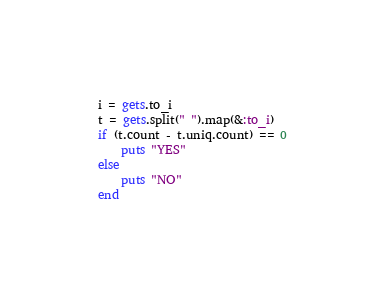<code> <loc_0><loc_0><loc_500><loc_500><_Ruby_>i = gets.to_i
t = gets.split(" ").map(&:to_i)
if (t.count - t.uniq.count) == 0
    puts "YES"
else
    puts "NO"
end
</code> 